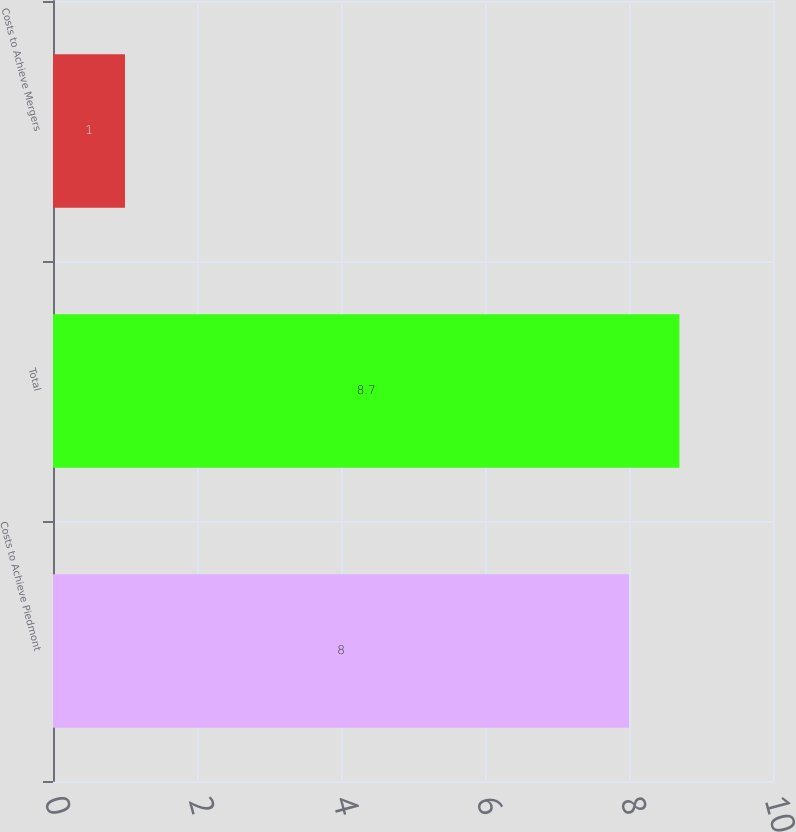Convert chart to OTSL. <chart><loc_0><loc_0><loc_500><loc_500><bar_chart><fcel>Costs to Achieve Piedmont<fcel>Total<fcel>Costs to Achieve Mergers<nl><fcel>8<fcel>8.7<fcel>1<nl></chart> 